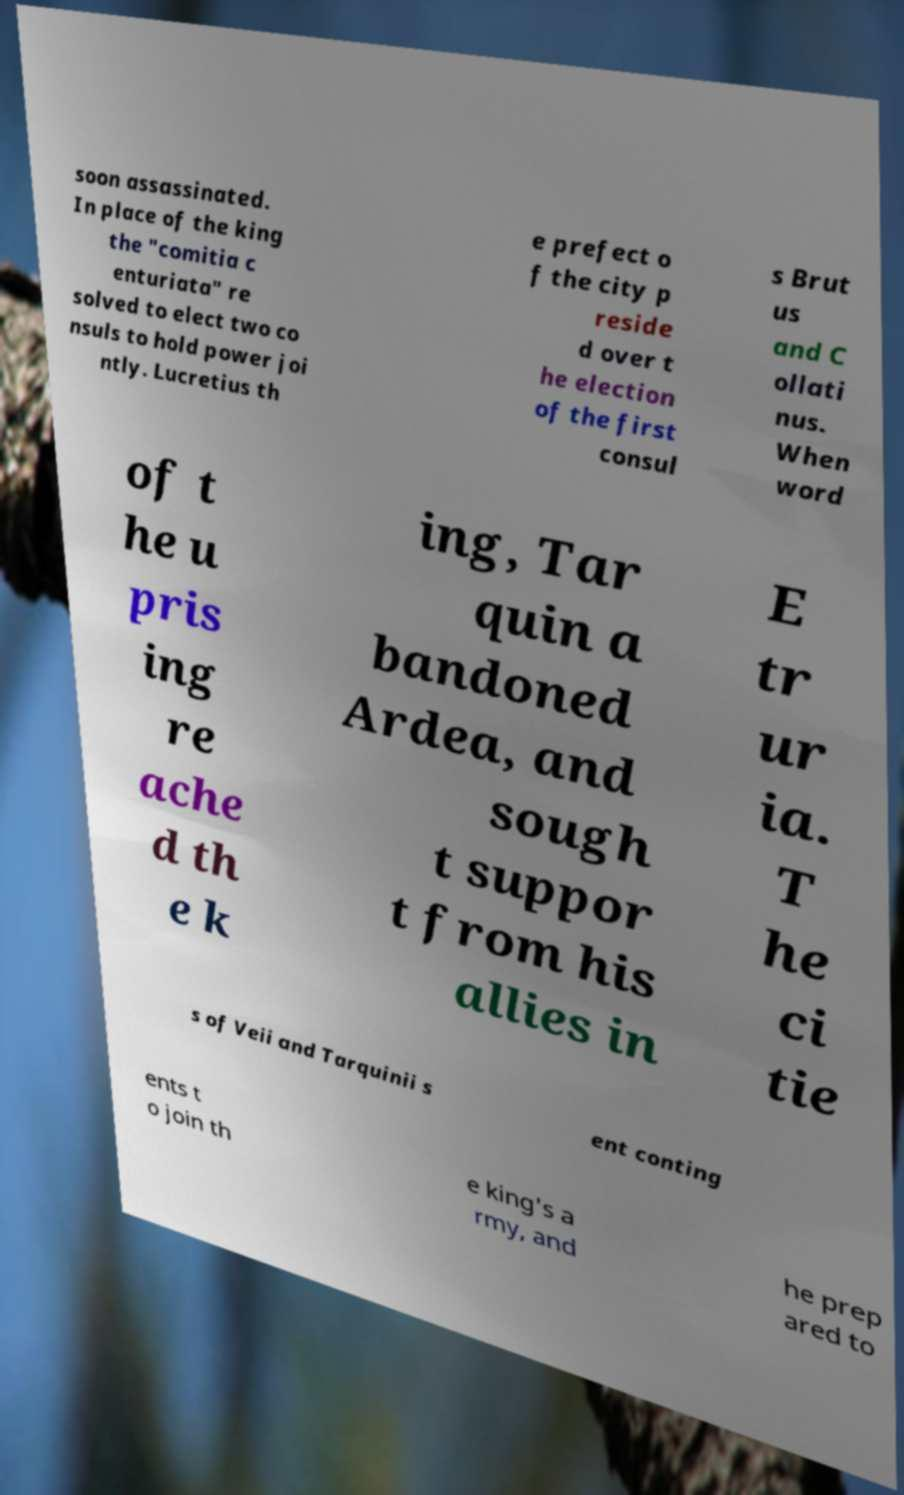Could you extract and type out the text from this image? soon assassinated. In place of the king the "comitia c enturiata" re solved to elect two co nsuls to hold power joi ntly. Lucretius th e prefect o f the city p reside d over t he election of the first consul s Brut us and C ollati nus. When word of t he u pris ing re ache d th e k ing, Tar quin a bandoned Ardea, and sough t suppor t from his allies in E tr ur ia. T he ci tie s of Veii and Tarquinii s ent conting ents t o join th e king's a rmy, and he prep ared to 